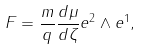Convert formula to latex. <formula><loc_0><loc_0><loc_500><loc_500>F = \frac { m } { q } \frac { d \mu } { d \zeta } e ^ { 2 } \wedge e ^ { 1 } ,</formula> 